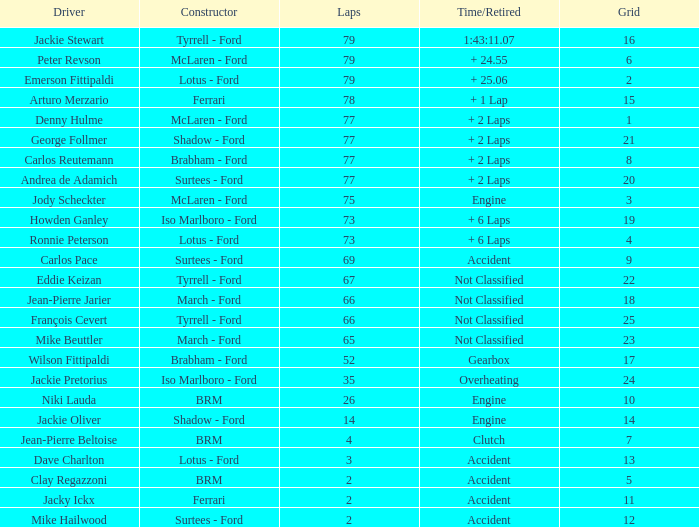How long does it take to finish less than 35 laps and fewer than 10 grids? Clutch, Accident. 